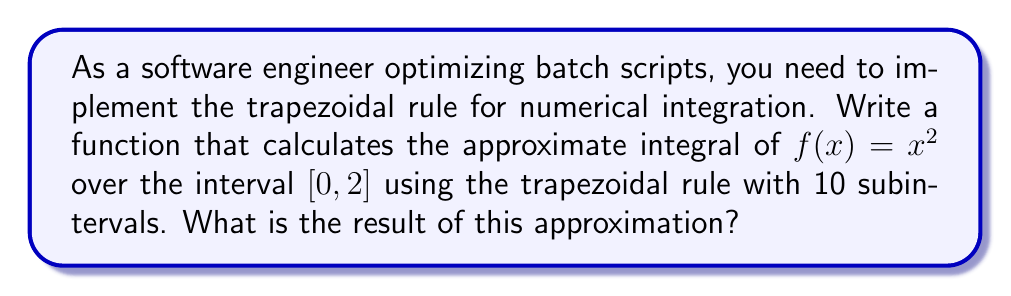Help me with this question. To solve this problem, we'll follow these steps:

1. Understand the trapezoidal rule formula:
   $$\int_a^b f(x) dx \approx \frac{h}{2} \left[f(x_0) + 2\sum_{i=1}^{n-1} f(x_i) + f(x_n)\right]$$
   where $h = \frac{b-a}{n}$, $n$ is the number of subintervals, and $x_i = a + ih$.

2. Define our parameters:
   $a = 0$, $b = 2$, $n = 10$, $f(x) = x^2$

3. Calculate $h$:
   $h = \frac{b-a}{n} = \frac{2-0}{10} = 0.2$

4. Generate $x_i$ values:
   $x_i = 0 + 0.2i$ for $i = 0, 1, ..., 10$

5. Calculate $f(x_i)$ values:
   $f(x_i) = (0.2i)^2$ for $i = 0, 1, ..., 10$

6. Apply the trapezoidal rule:
   $$\begin{align*}
   \text{Integral} &\approx \frac{0.2}{2} \left[f(0) + 2\sum_{i=1}^{9} f(0.2i) + f(2)\right] \\
   &= 0.1 \left[0^2 + 2(0.2^2 + 0.4^2 + ... + 1.8^2) + 2^2\right] \\
   &= 0.1 \left[0 + 2(0.04 + 0.16 + 0.36 + 0.64 + 1 + 1.44 + 1.96 + 2.56 + 3.24) + 4\right] \\
   &= 0.1 [0 + 2(11.4) + 4] \\
   &= 0.1 [22.8 + 4] \\
   &= 0.1 [26.8] \\
   &= 2.68
   \end{align*}$$
Answer: 2.68 